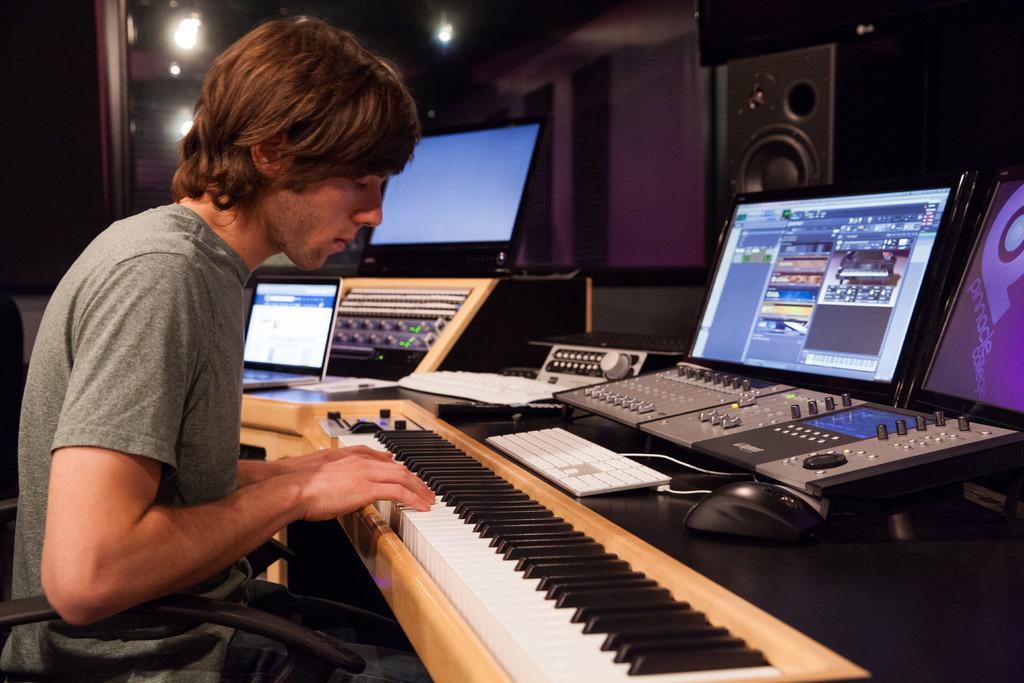Can you describe this image briefly? The image is inside the restaurant. In the image there is a man sitting on chair and playing his musical keyboard. On musical keyboard we can also see a laptop,monitor,screen,speaker. In background there is a wall which is in pink color on top there are few lights. 